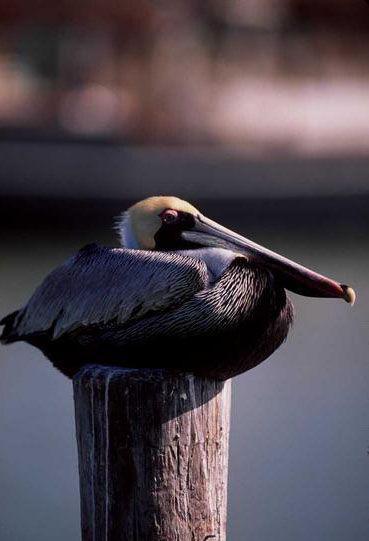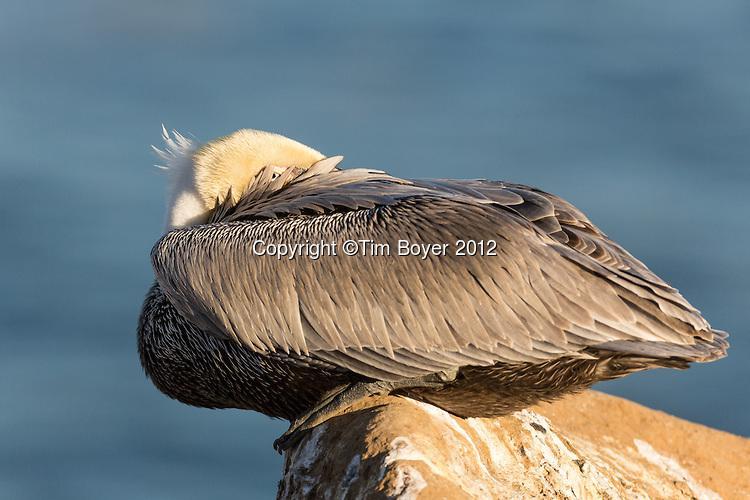The first image is the image on the left, the second image is the image on the right. For the images shown, is this caption "One bird is on a pole pointed to the right." true? Answer yes or no. Yes. The first image is the image on the left, the second image is the image on the right. Evaluate the accuracy of this statement regarding the images: "Each image shows a pelican posed with its head and body flattened, and in one image a pelican is sitting atop a flat post.". Is it true? Answer yes or no. Yes. 